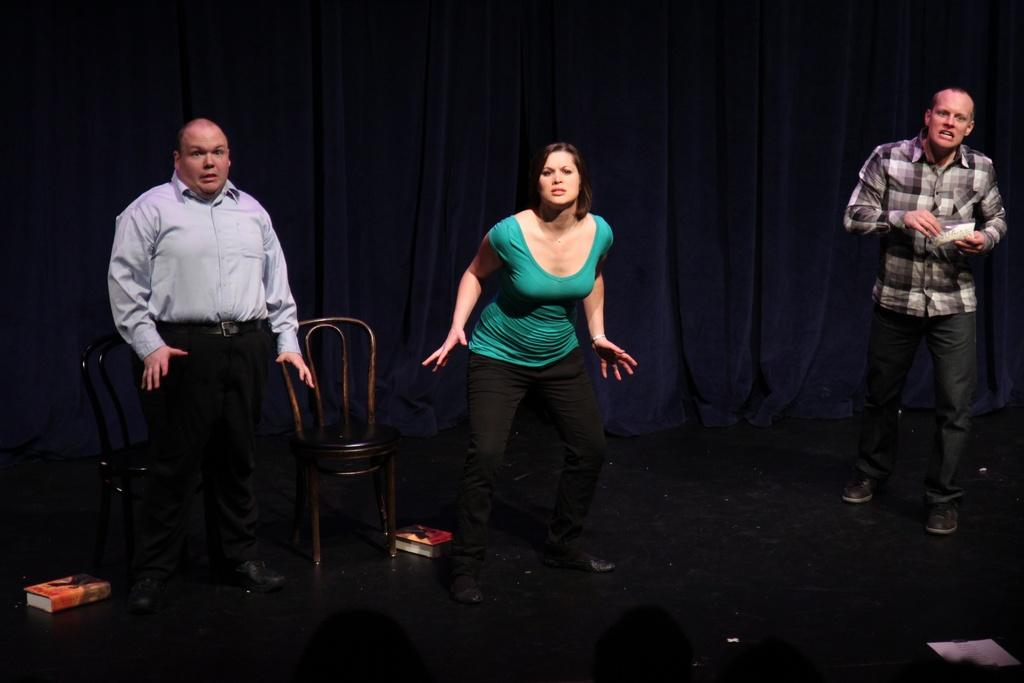How many people are in the picture? There are three people in the picture. Can you describe the gender of the people? Two of them are men, and the middle person is a woman. Where are the people standing? The people are standing on the floor. What furniture can be seen in the image? There is a chair in the image. What is visible in the background of the image? There is a curtain in the background of the image. What type of air can be seen surrounding the people in the image? There is no specific type of air visible in the image; it is simply the ambient air surrounding the people. Can you tell me how many chickens are present in the image? There are no chickens present in the image. 